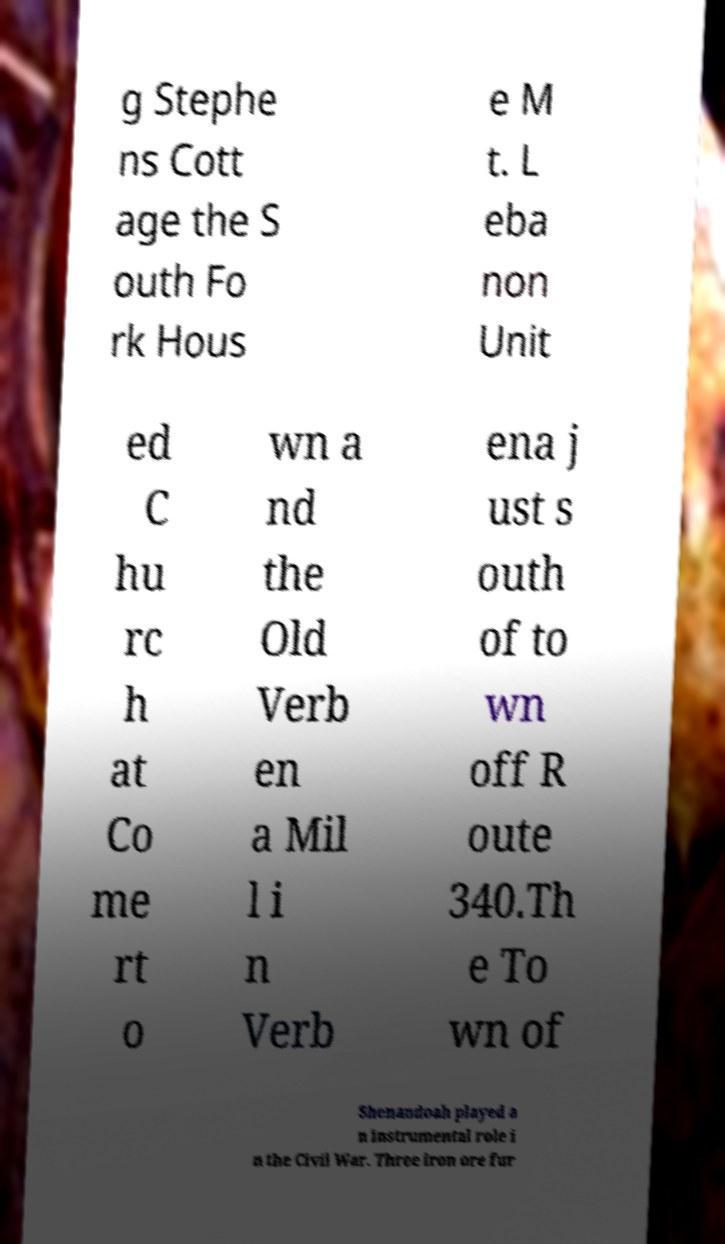Could you assist in decoding the text presented in this image and type it out clearly? g Stephe ns Cott age the S outh Fo rk Hous e M t. L eba non Unit ed C hu rc h at Co me rt o wn a nd the Old Verb en a Mil l i n Verb ena j ust s outh of to wn off R oute 340.Th e To wn of Shenandoah played a n instrumental role i n the Civil War. Three iron ore fur 